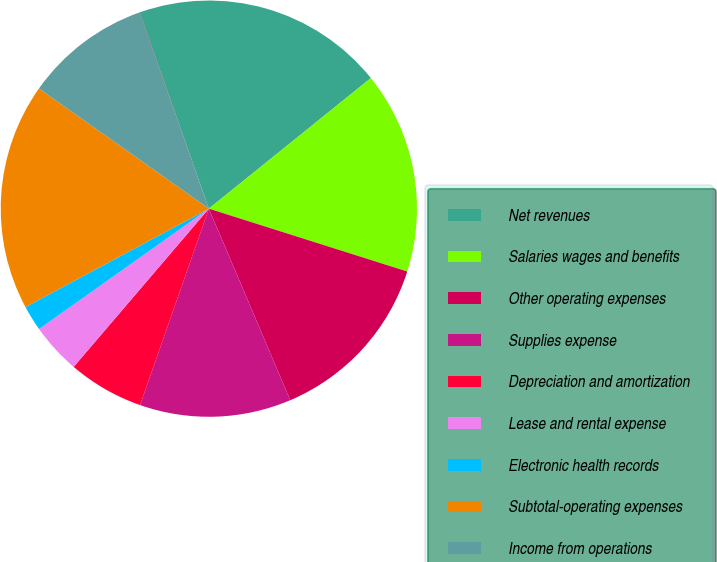Convert chart to OTSL. <chart><loc_0><loc_0><loc_500><loc_500><pie_chart><fcel>Net revenues<fcel>Salaries wages and benefits<fcel>Other operating expenses<fcel>Supplies expense<fcel>Depreciation and amortization<fcel>Lease and rental expense<fcel>Electronic health records<fcel>Subtotal-operating expenses<fcel>Income from operations<fcel>Interest expense net<nl><fcel>19.59%<fcel>15.68%<fcel>13.72%<fcel>11.76%<fcel>5.89%<fcel>3.93%<fcel>1.98%<fcel>17.63%<fcel>9.8%<fcel>0.02%<nl></chart> 